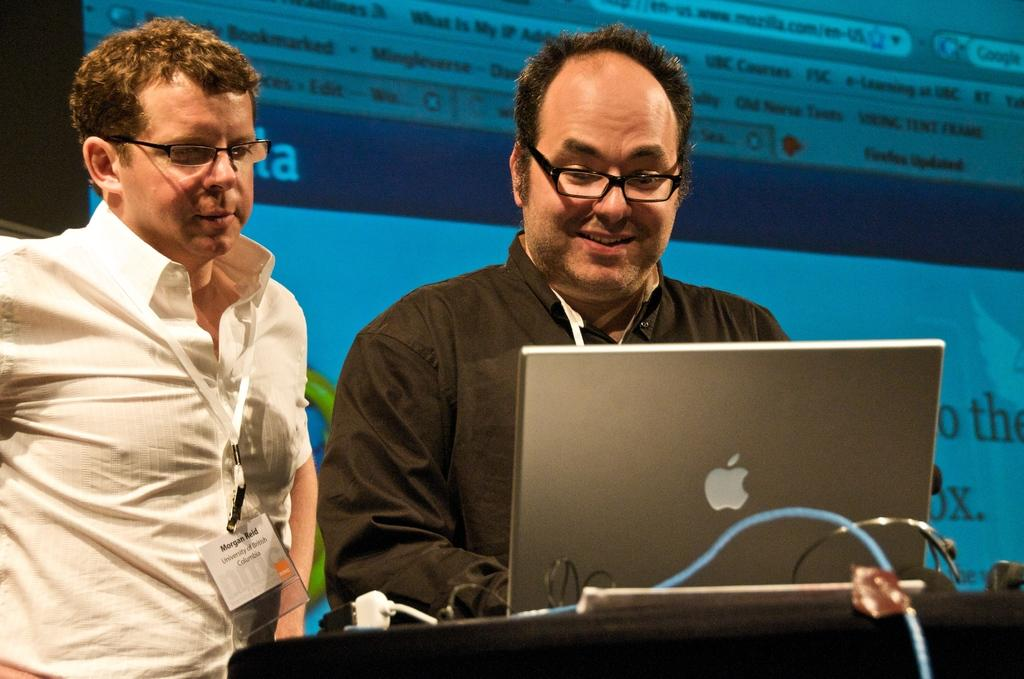How many people are in the image? There are two people in the image. What are the people doing in the image? The two people are standing. What are the people wearing in the image? Both people are wearing white shirts. What can be seen in the background of the image? There is a screen visible in the background of the image. What type of branch is the pet holding in the image? There is no branch or pet present in the image. 